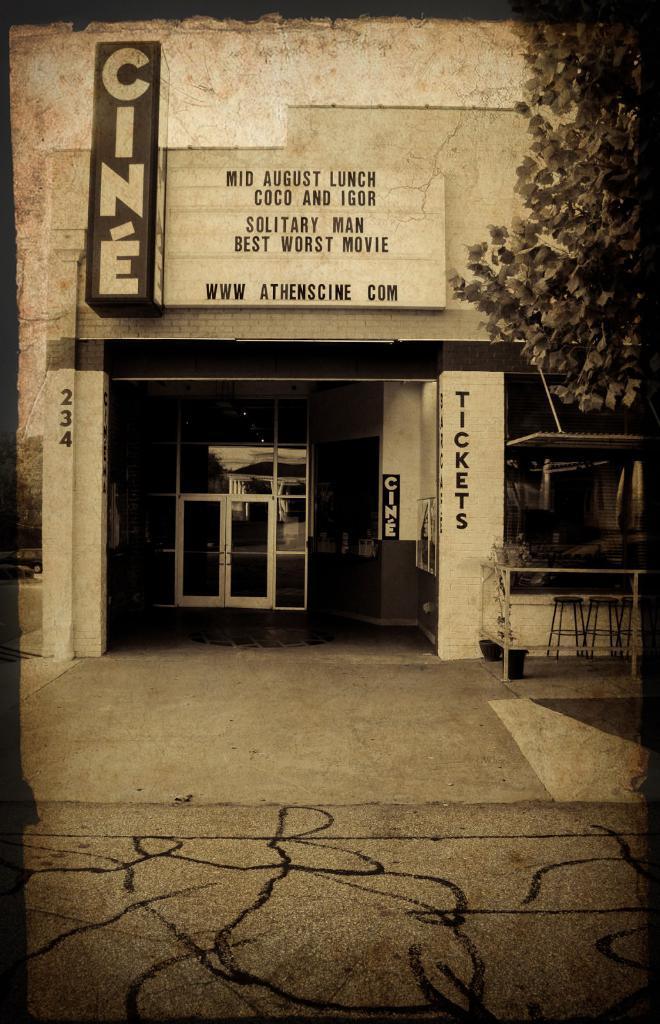Can you describe this image briefly? In the center of the image there is a building and we can see a board on it. There is a door. At the bottom there is a road. On the right we can see a tree. 